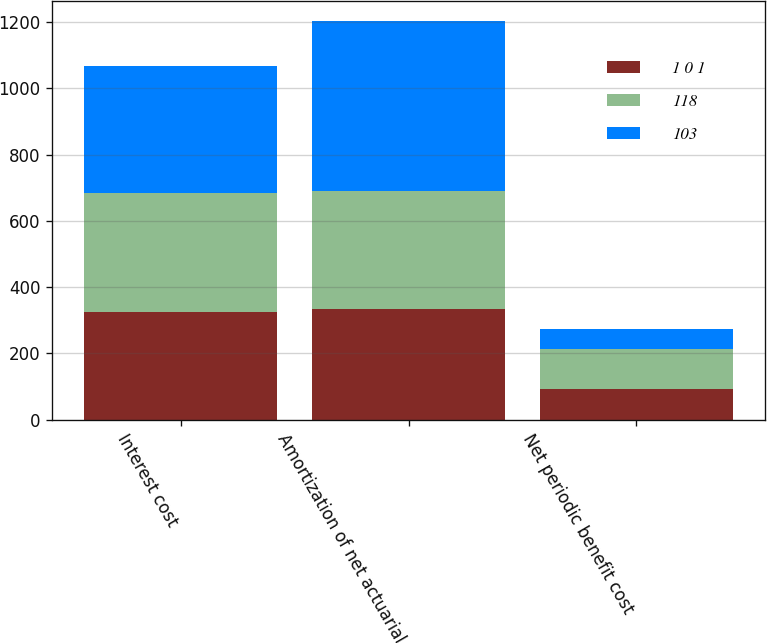Convert chart. <chart><loc_0><loc_0><loc_500><loc_500><stacked_bar_chart><ecel><fcel>Interest cost<fcel>Amortization of net actuarial<fcel>Net periodic benefit cost<nl><fcel>1 0 1<fcel>326<fcel>333<fcel>94<nl><fcel>118<fcel>357<fcel>357<fcel>118<nl><fcel>103<fcel>385<fcel>512<fcel>61<nl></chart> 